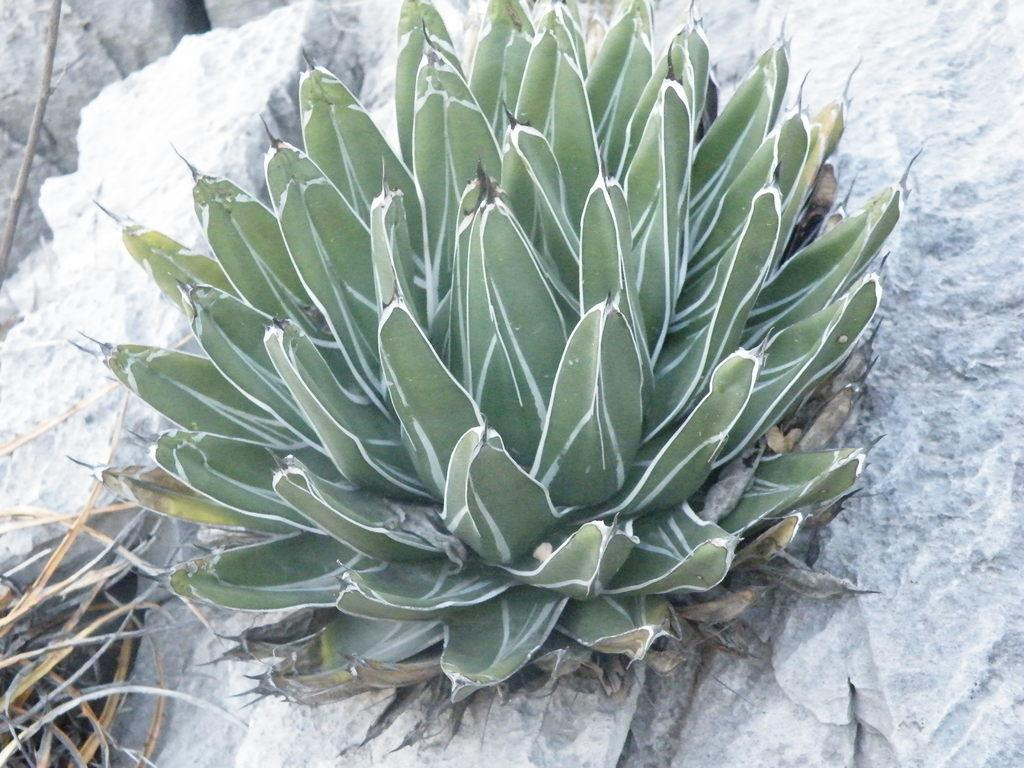What type of plant is in the center of the image? There is an agave plant in the center of the image. What type of haircut does the agave plant have in the image? The agave plant does not have a haircut, as it is a plant and not a person. 